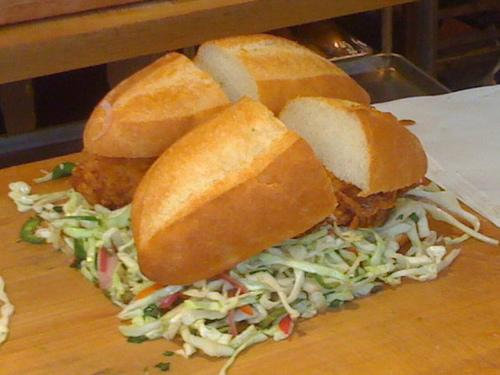How many people is this food for most likely?

Choices:
A) eight
B) two
C) one
D) twenty two 